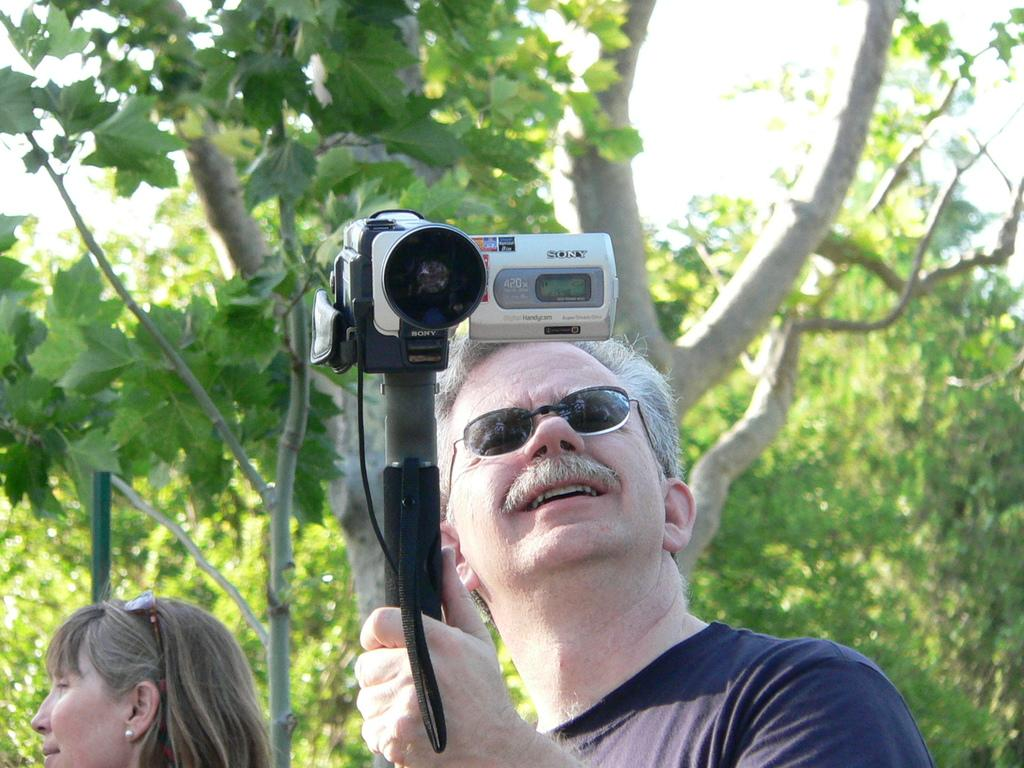What is the man in the image holding? The man is holding a camera in the image. Who else is present in the image? There is a woman in the image. What can be seen in the background of the image? There are trees in the background of the image. What day of the week is depicted in the image? The day of the week is not depicted in the image; there is no information about the day of the week. 